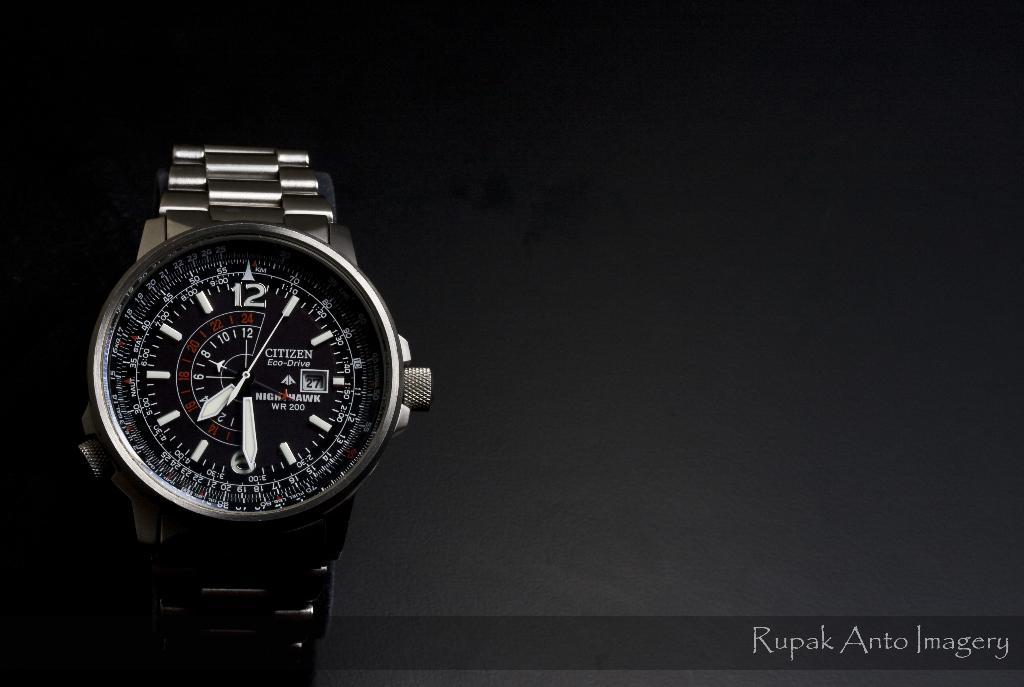<image>
Offer a succinct explanation of the picture presented. Face of a watch which has the word CITIZEN on the front. 